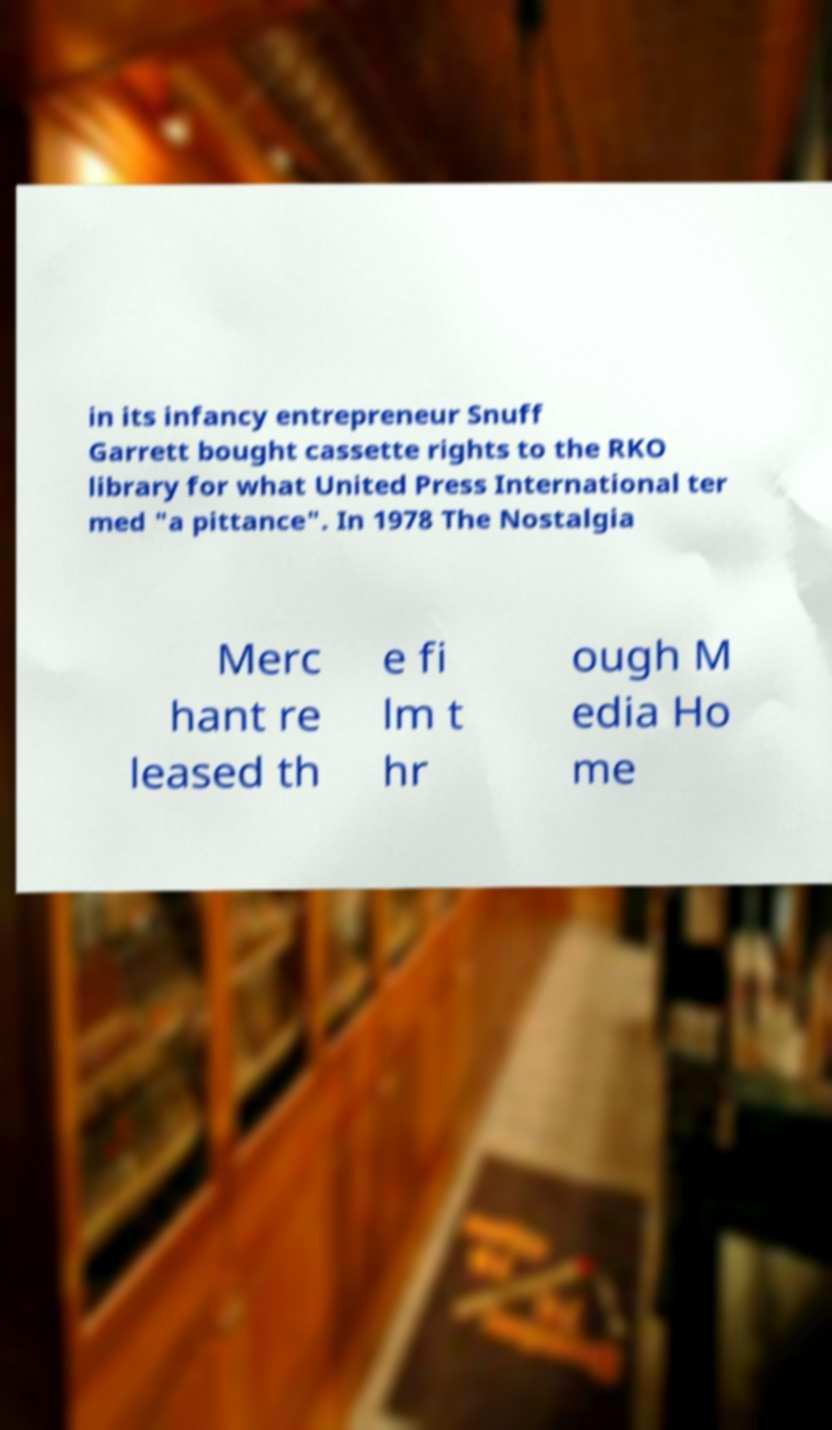Can you accurately transcribe the text from the provided image for me? in its infancy entrepreneur Snuff Garrett bought cassette rights to the RKO library for what United Press International ter med "a pittance". In 1978 The Nostalgia Merc hant re leased th e fi lm t hr ough M edia Ho me 